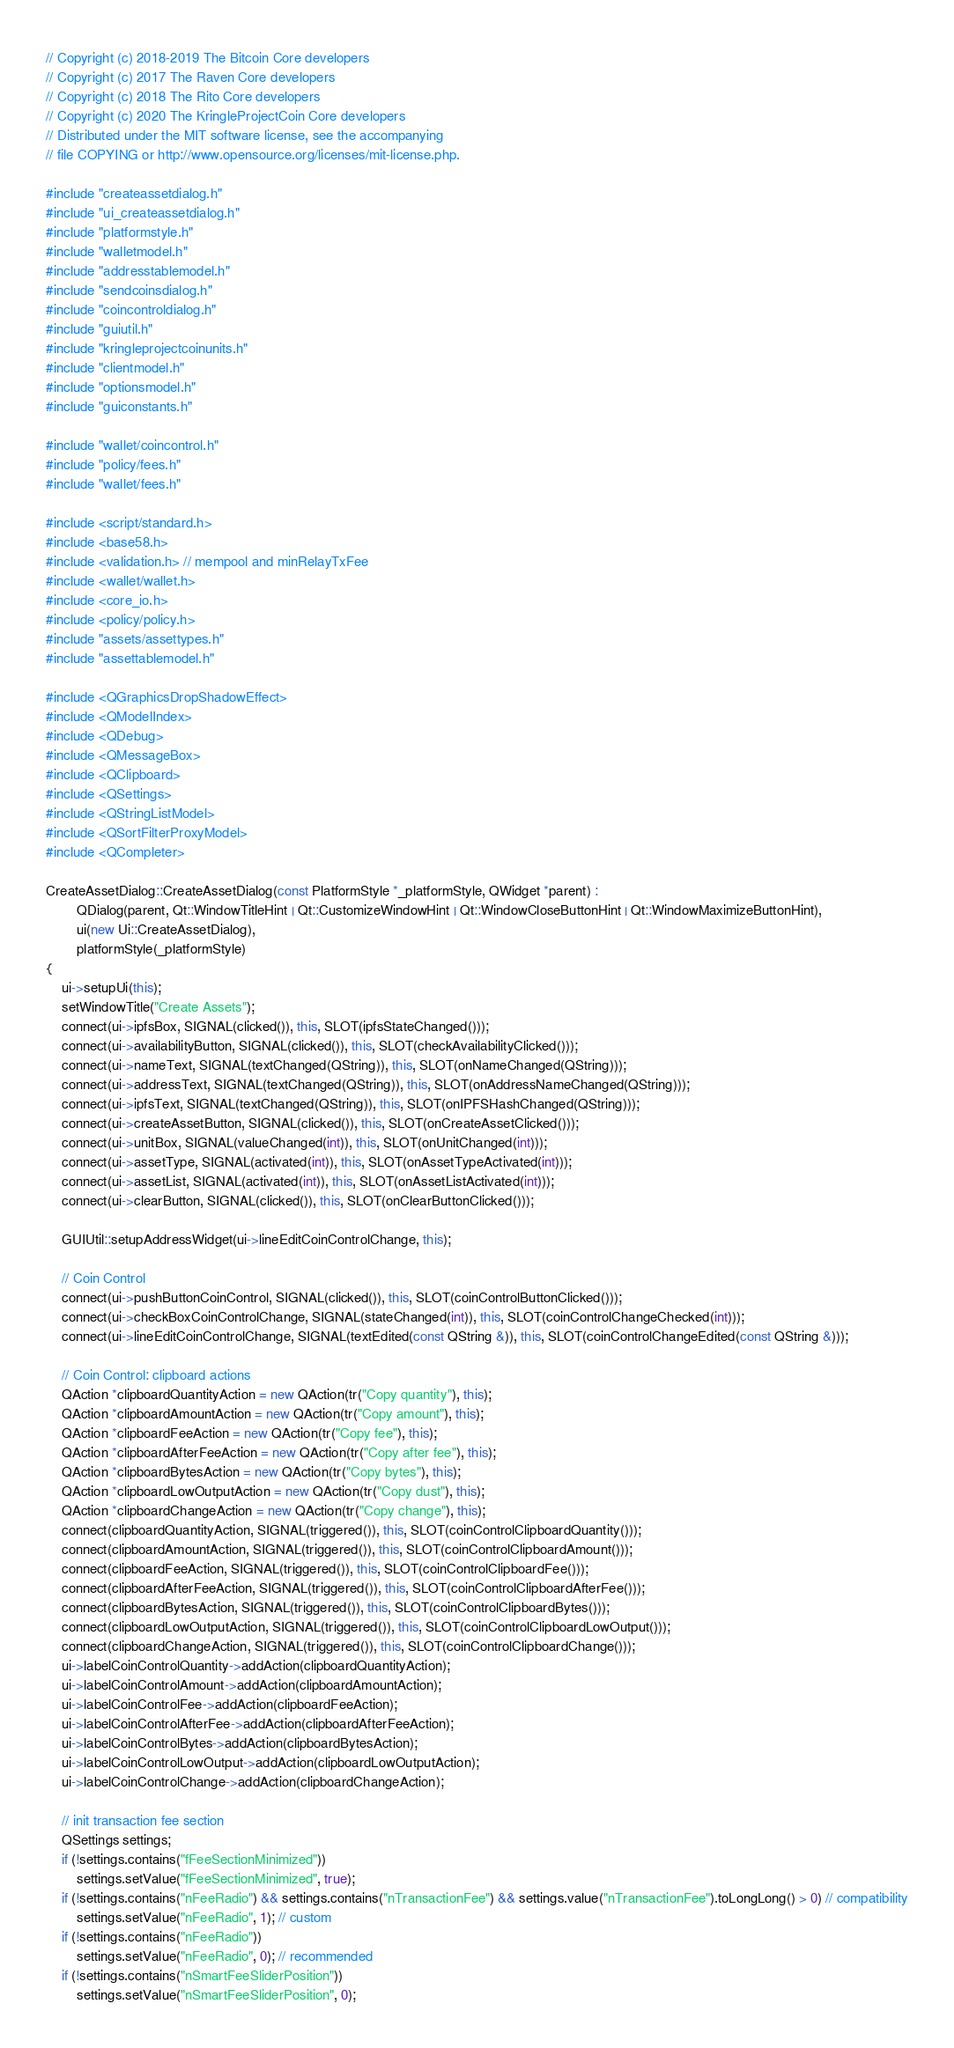Convert code to text. <code><loc_0><loc_0><loc_500><loc_500><_C++_>// Copyright (c) 2018-2019 The Bitcoin Core developers
// Copyright (c) 2017 The Raven Core developers
// Copyright (c) 2018 The Rito Core developers
// Copyright (c) 2020 The KringleProjectCoin Core developers
// Distributed under the MIT software license, see the accompanying
// file COPYING or http://www.opensource.org/licenses/mit-license.php.

#include "createassetdialog.h"
#include "ui_createassetdialog.h"
#include "platformstyle.h"
#include "walletmodel.h"
#include "addresstablemodel.h"
#include "sendcoinsdialog.h"
#include "coincontroldialog.h"
#include "guiutil.h"
#include "kringleprojectcoinunits.h"
#include "clientmodel.h"
#include "optionsmodel.h"
#include "guiconstants.h"

#include "wallet/coincontrol.h"
#include "policy/fees.h"
#include "wallet/fees.h"

#include <script/standard.h>
#include <base58.h>
#include <validation.h> // mempool and minRelayTxFee
#include <wallet/wallet.h>
#include <core_io.h>
#include <policy/policy.h>
#include "assets/assettypes.h"
#include "assettablemodel.h"

#include <QGraphicsDropShadowEffect>
#include <QModelIndex>
#include <QDebug>
#include <QMessageBox>
#include <QClipboard>
#include <QSettings>
#include <QStringListModel>
#include <QSortFilterProxyModel>
#include <QCompleter>

CreateAssetDialog::CreateAssetDialog(const PlatformStyle *_platformStyle, QWidget *parent) :
        QDialog(parent, Qt::WindowTitleHint | Qt::CustomizeWindowHint | Qt::WindowCloseButtonHint | Qt::WindowMaximizeButtonHint),
        ui(new Ui::CreateAssetDialog),
        platformStyle(_platformStyle)
{
    ui->setupUi(this);
    setWindowTitle("Create Assets");
    connect(ui->ipfsBox, SIGNAL(clicked()), this, SLOT(ipfsStateChanged()));
    connect(ui->availabilityButton, SIGNAL(clicked()), this, SLOT(checkAvailabilityClicked()));
    connect(ui->nameText, SIGNAL(textChanged(QString)), this, SLOT(onNameChanged(QString)));
    connect(ui->addressText, SIGNAL(textChanged(QString)), this, SLOT(onAddressNameChanged(QString)));
    connect(ui->ipfsText, SIGNAL(textChanged(QString)), this, SLOT(onIPFSHashChanged(QString)));
    connect(ui->createAssetButton, SIGNAL(clicked()), this, SLOT(onCreateAssetClicked()));
    connect(ui->unitBox, SIGNAL(valueChanged(int)), this, SLOT(onUnitChanged(int)));
    connect(ui->assetType, SIGNAL(activated(int)), this, SLOT(onAssetTypeActivated(int)));
    connect(ui->assetList, SIGNAL(activated(int)), this, SLOT(onAssetListActivated(int)));
    connect(ui->clearButton, SIGNAL(clicked()), this, SLOT(onClearButtonClicked()));

    GUIUtil::setupAddressWidget(ui->lineEditCoinControlChange, this);

    // Coin Control
    connect(ui->pushButtonCoinControl, SIGNAL(clicked()), this, SLOT(coinControlButtonClicked()));
    connect(ui->checkBoxCoinControlChange, SIGNAL(stateChanged(int)), this, SLOT(coinControlChangeChecked(int)));
    connect(ui->lineEditCoinControlChange, SIGNAL(textEdited(const QString &)), this, SLOT(coinControlChangeEdited(const QString &)));

    // Coin Control: clipboard actions
    QAction *clipboardQuantityAction = new QAction(tr("Copy quantity"), this);
    QAction *clipboardAmountAction = new QAction(tr("Copy amount"), this);
    QAction *clipboardFeeAction = new QAction(tr("Copy fee"), this);
    QAction *clipboardAfterFeeAction = new QAction(tr("Copy after fee"), this);
    QAction *clipboardBytesAction = new QAction(tr("Copy bytes"), this);
    QAction *clipboardLowOutputAction = new QAction(tr("Copy dust"), this);
    QAction *clipboardChangeAction = new QAction(tr("Copy change"), this);
    connect(clipboardQuantityAction, SIGNAL(triggered()), this, SLOT(coinControlClipboardQuantity()));
    connect(clipboardAmountAction, SIGNAL(triggered()), this, SLOT(coinControlClipboardAmount()));
    connect(clipboardFeeAction, SIGNAL(triggered()), this, SLOT(coinControlClipboardFee()));
    connect(clipboardAfterFeeAction, SIGNAL(triggered()), this, SLOT(coinControlClipboardAfterFee()));
    connect(clipboardBytesAction, SIGNAL(triggered()), this, SLOT(coinControlClipboardBytes()));
    connect(clipboardLowOutputAction, SIGNAL(triggered()), this, SLOT(coinControlClipboardLowOutput()));
    connect(clipboardChangeAction, SIGNAL(triggered()), this, SLOT(coinControlClipboardChange()));
    ui->labelCoinControlQuantity->addAction(clipboardQuantityAction);
    ui->labelCoinControlAmount->addAction(clipboardAmountAction);
    ui->labelCoinControlFee->addAction(clipboardFeeAction);
    ui->labelCoinControlAfterFee->addAction(clipboardAfterFeeAction);
    ui->labelCoinControlBytes->addAction(clipboardBytesAction);
    ui->labelCoinControlLowOutput->addAction(clipboardLowOutputAction);
    ui->labelCoinControlChange->addAction(clipboardChangeAction);

    // init transaction fee section
    QSettings settings;
    if (!settings.contains("fFeeSectionMinimized"))
        settings.setValue("fFeeSectionMinimized", true);
    if (!settings.contains("nFeeRadio") && settings.contains("nTransactionFee") && settings.value("nTransactionFee").toLongLong() > 0) // compatibility
        settings.setValue("nFeeRadio", 1); // custom
    if (!settings.contains("nFeeRadio"))
        settings.setValue("nFeeRadio", 0); // recommended
    if (!settings.contains("nSmartFeeSliderPosition"))
        settings.setValue("nSmartFeeSliderPosition", 0);</code> 